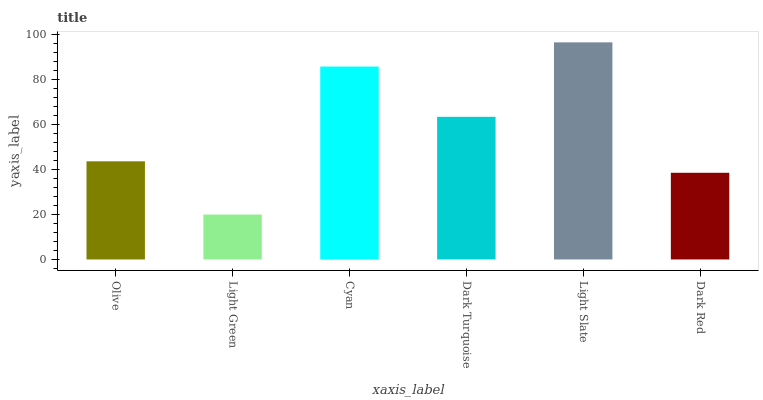Is Light Green the minimum?
Answer yes or no. Yes. Is Light Slate the maximum?
Answer yes or no. Yes. Is Cyan the minimum?
Answer yes or no. No. Is Cyan the maximum?
Answer yes or no. No. Is Cyan greater than Light Green?
Answer yes or no. Yes. Is Light Green less than Cyan?
Answer yes or no. Yes. Is Light Green greater than Cyan?
Answer yes or no. No. Is Cyan less than Light Green?
Answer yes or no. No. Is Dark Turquoise the high median?
Answer yes or no. Yes. Is Olive the low median?
Answer yes or no. Yes. Is Cyan the high median?
Answer yes or no. No. Is Light Green the low median?
Answer yes or no. No. 